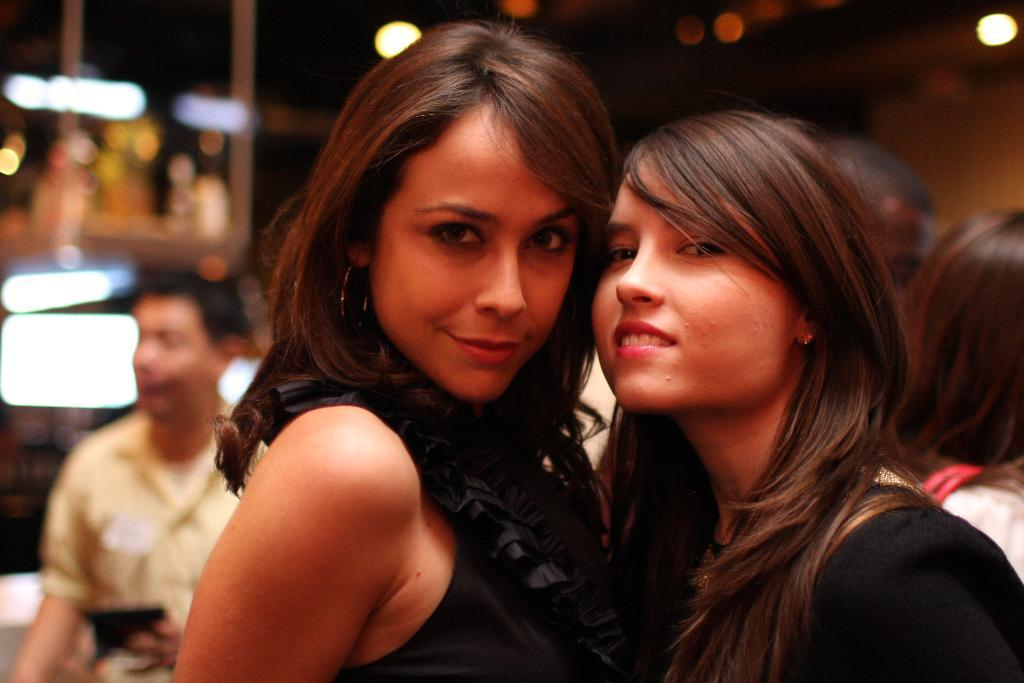What are the women in the image doing? The women in the front of the image are standing and smiling. Can you describe the man in the image? The man is standing in the background of the image and is wearing a yellow shirt. What can be seen in the image that provides illumination? There are lights visible in the image. What type of lace can be seen on the man's shirt in the image? The man's shirt in the image is a solid yellow color, and there is no lace visible. What does the image smell like? The image is a visual representation and does not have a smell. 